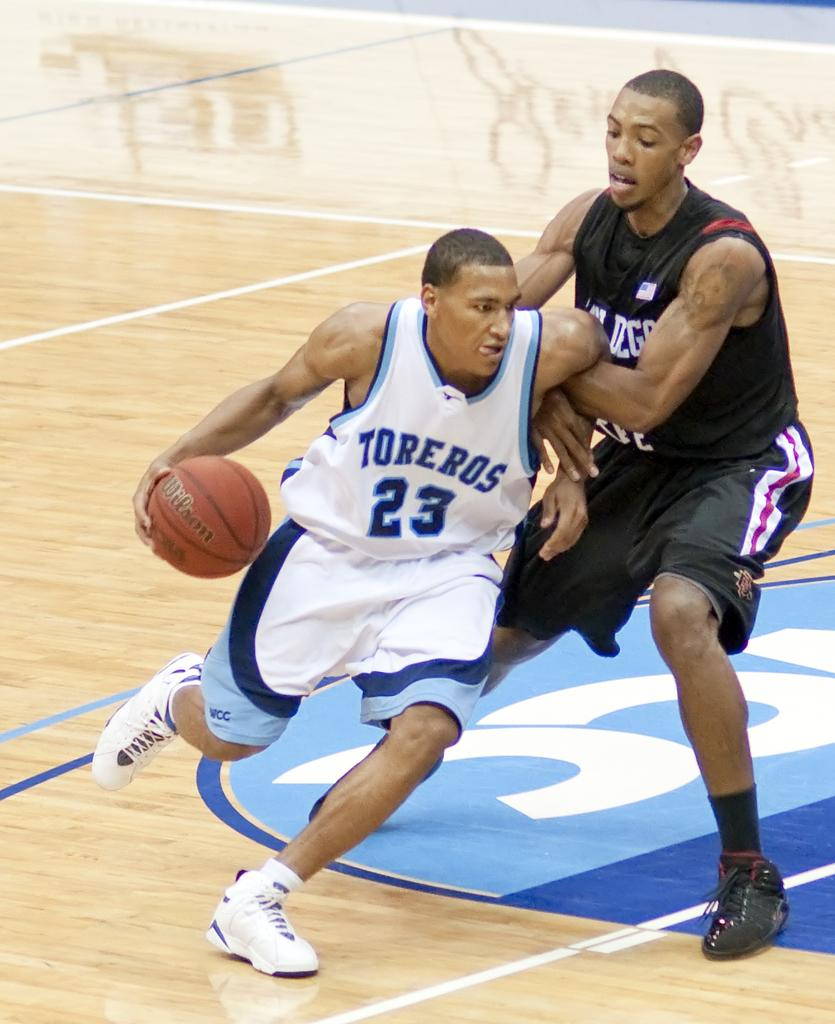Provide a one-sentence caption for the provided image. Toreros attempts to get past the enemy teams defense while playing basketball. 